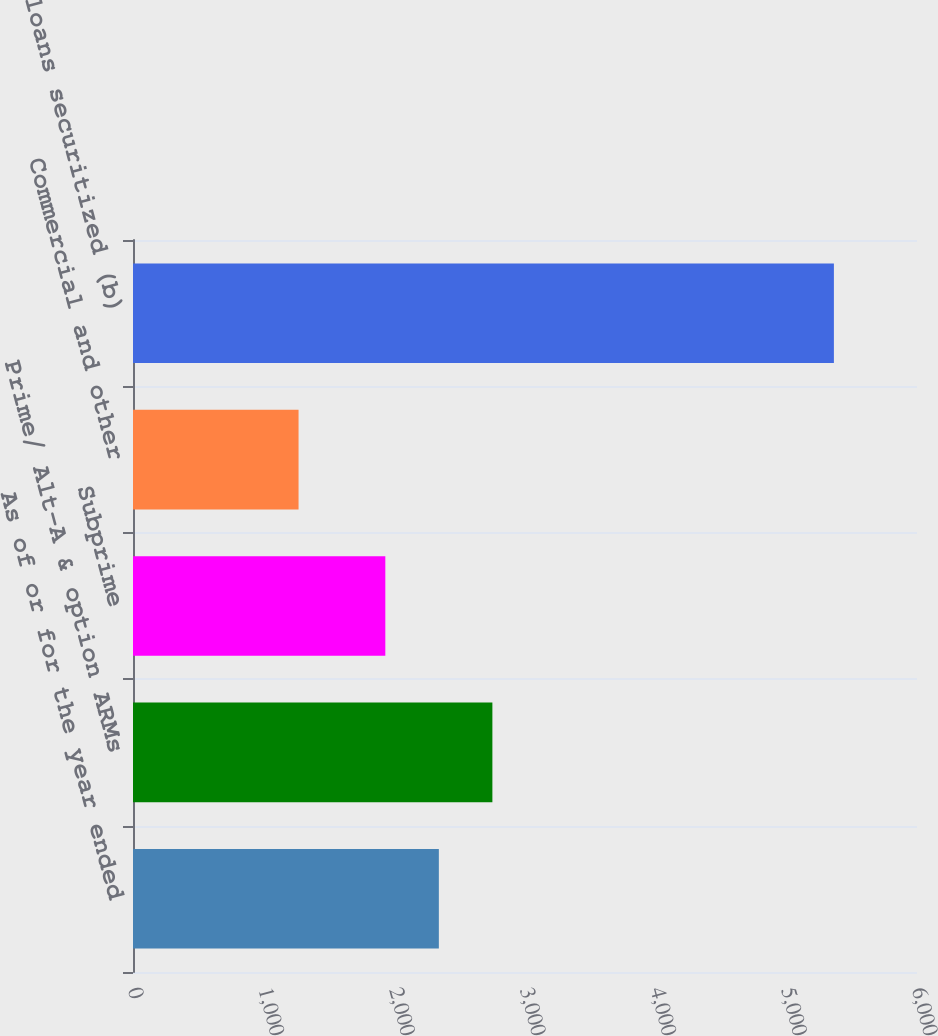<chart> <loc_0><loc_0><loc_500><loc_500><bar_chart><fcel>As of or for the year ended<fcel>Prime/ Alt-A & option ARMs<fcel>Subprime<fcel>Commercial and other<fcel>Total loans securitized (b)<nl><fcel>2340.7<fcel>2750.4<fcel>1931<fcel>1267<fcel>5364<nl></chart> 